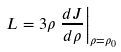<formula> <loc_0><loc_0><loc_500><loc_500>L = 3 \rho \left . \frac { d J } { d \rho } \right | _ { \rho = \rho _ { 0 } }</formula> 